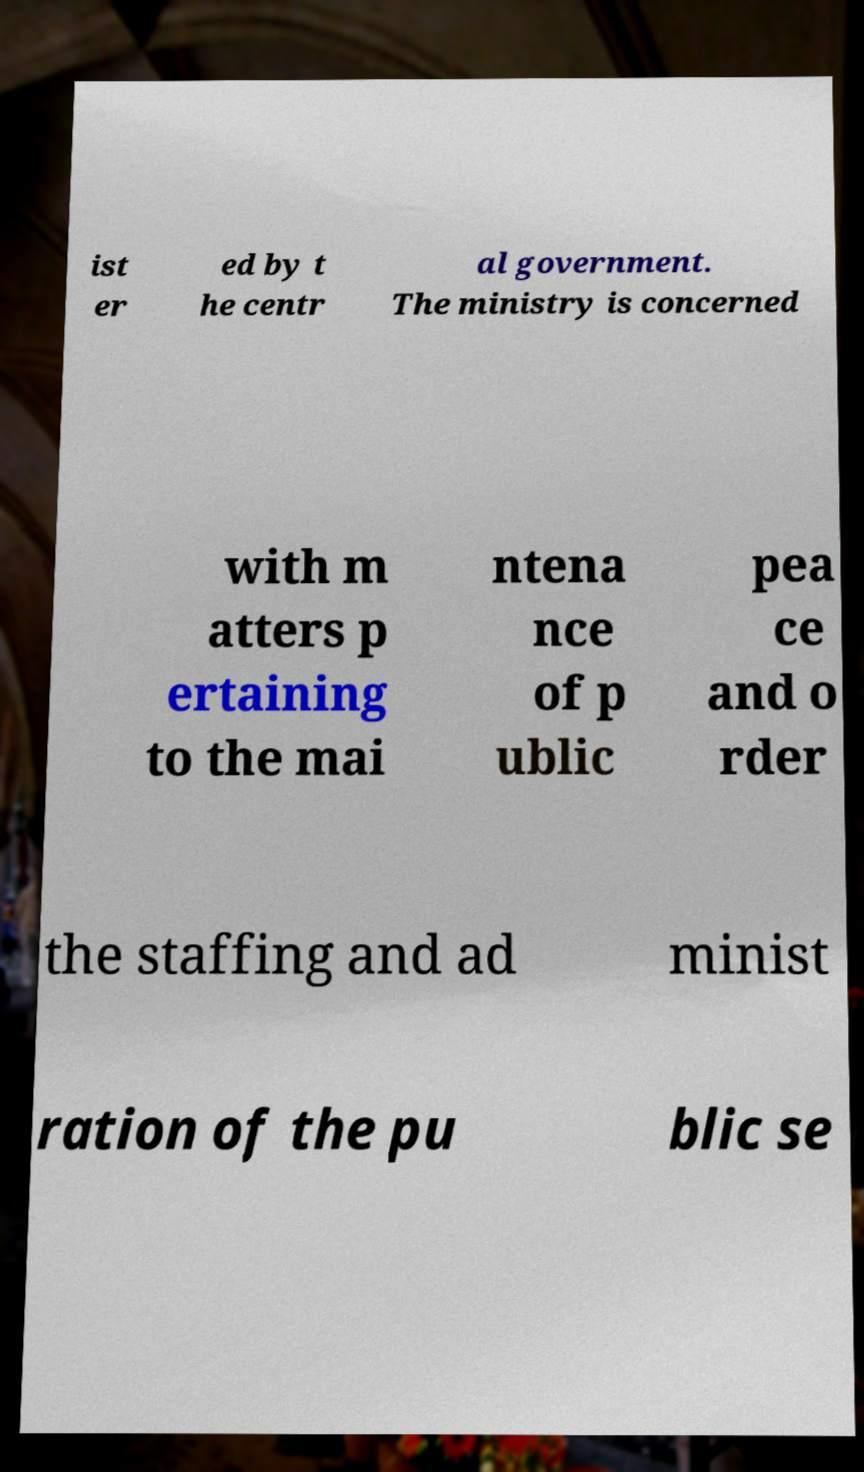For documentation purposes, I need the text within this image transcribed. Could you provide that? ist er ed by t he centr al government. The ministry is concerned with m atters p ertaining to the mai ntena nce of p ublic pea ce and o rder the staffing and ad minist ration of the pu blic se 